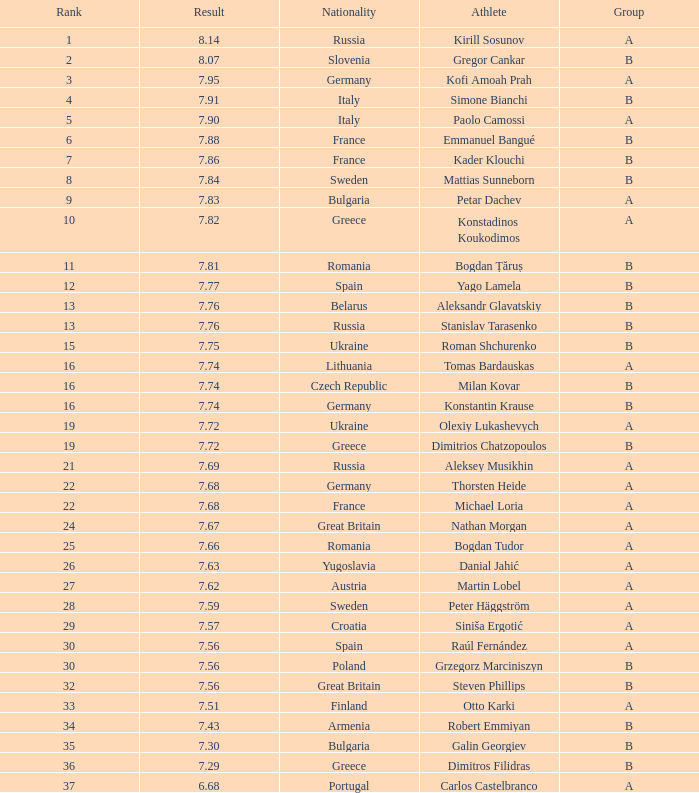Which sportsperson's standing is over 15 when the score is under Steven Phillips. 